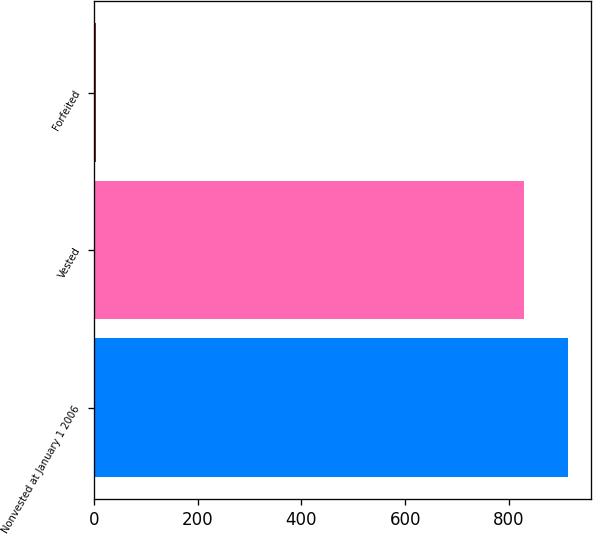Convert chart to OTSL. <chart><loc_0><loc_0><loc_500><loc_500><bar_chart><fcel>Nonvested at January 1 2006<fcel>Vested<fcel>Forfeited<nl><fcel>913<fcel>830<fcel>4<nl></chart> 